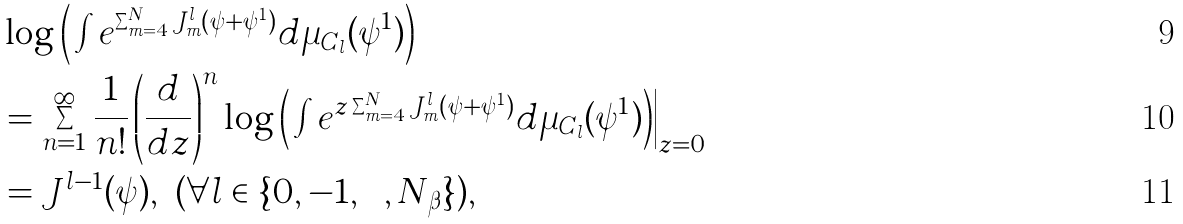<formula> <loc_0><loc_0><loc_500><loc_500>& \log \Big ( \int e ^ { \sum _ { m = 4 } ^ { N } J _ { m } ^ { l } ( \psi + \psi ^ { 1 } ) } d \mu _ { C _ { l } } ( \psi ^ { 1 } ) \Big ) \\ & = \sum _ { n = 1 } ^ { \infty } \frac { 1 } { n ! } \left ( \frac { d } { d z } \right ) ^ { n } \log \Big ( \int e ^ { z \sum _ { m = 4 } ^ { N } J _ { m } ^ { l } ( \psi + \psi ^ { 1 } ) } d \mu _ { C _ { l } } ( \psi ^ { 1 } ) \Big ) \Big | _ { z = 0 } \\ & = J ^ { l - 1 } ( \psi ) , \ ( \forall l \in \{ 0 , - 1 , \cdots , N _ { \beta } \} ) ,</formula> 